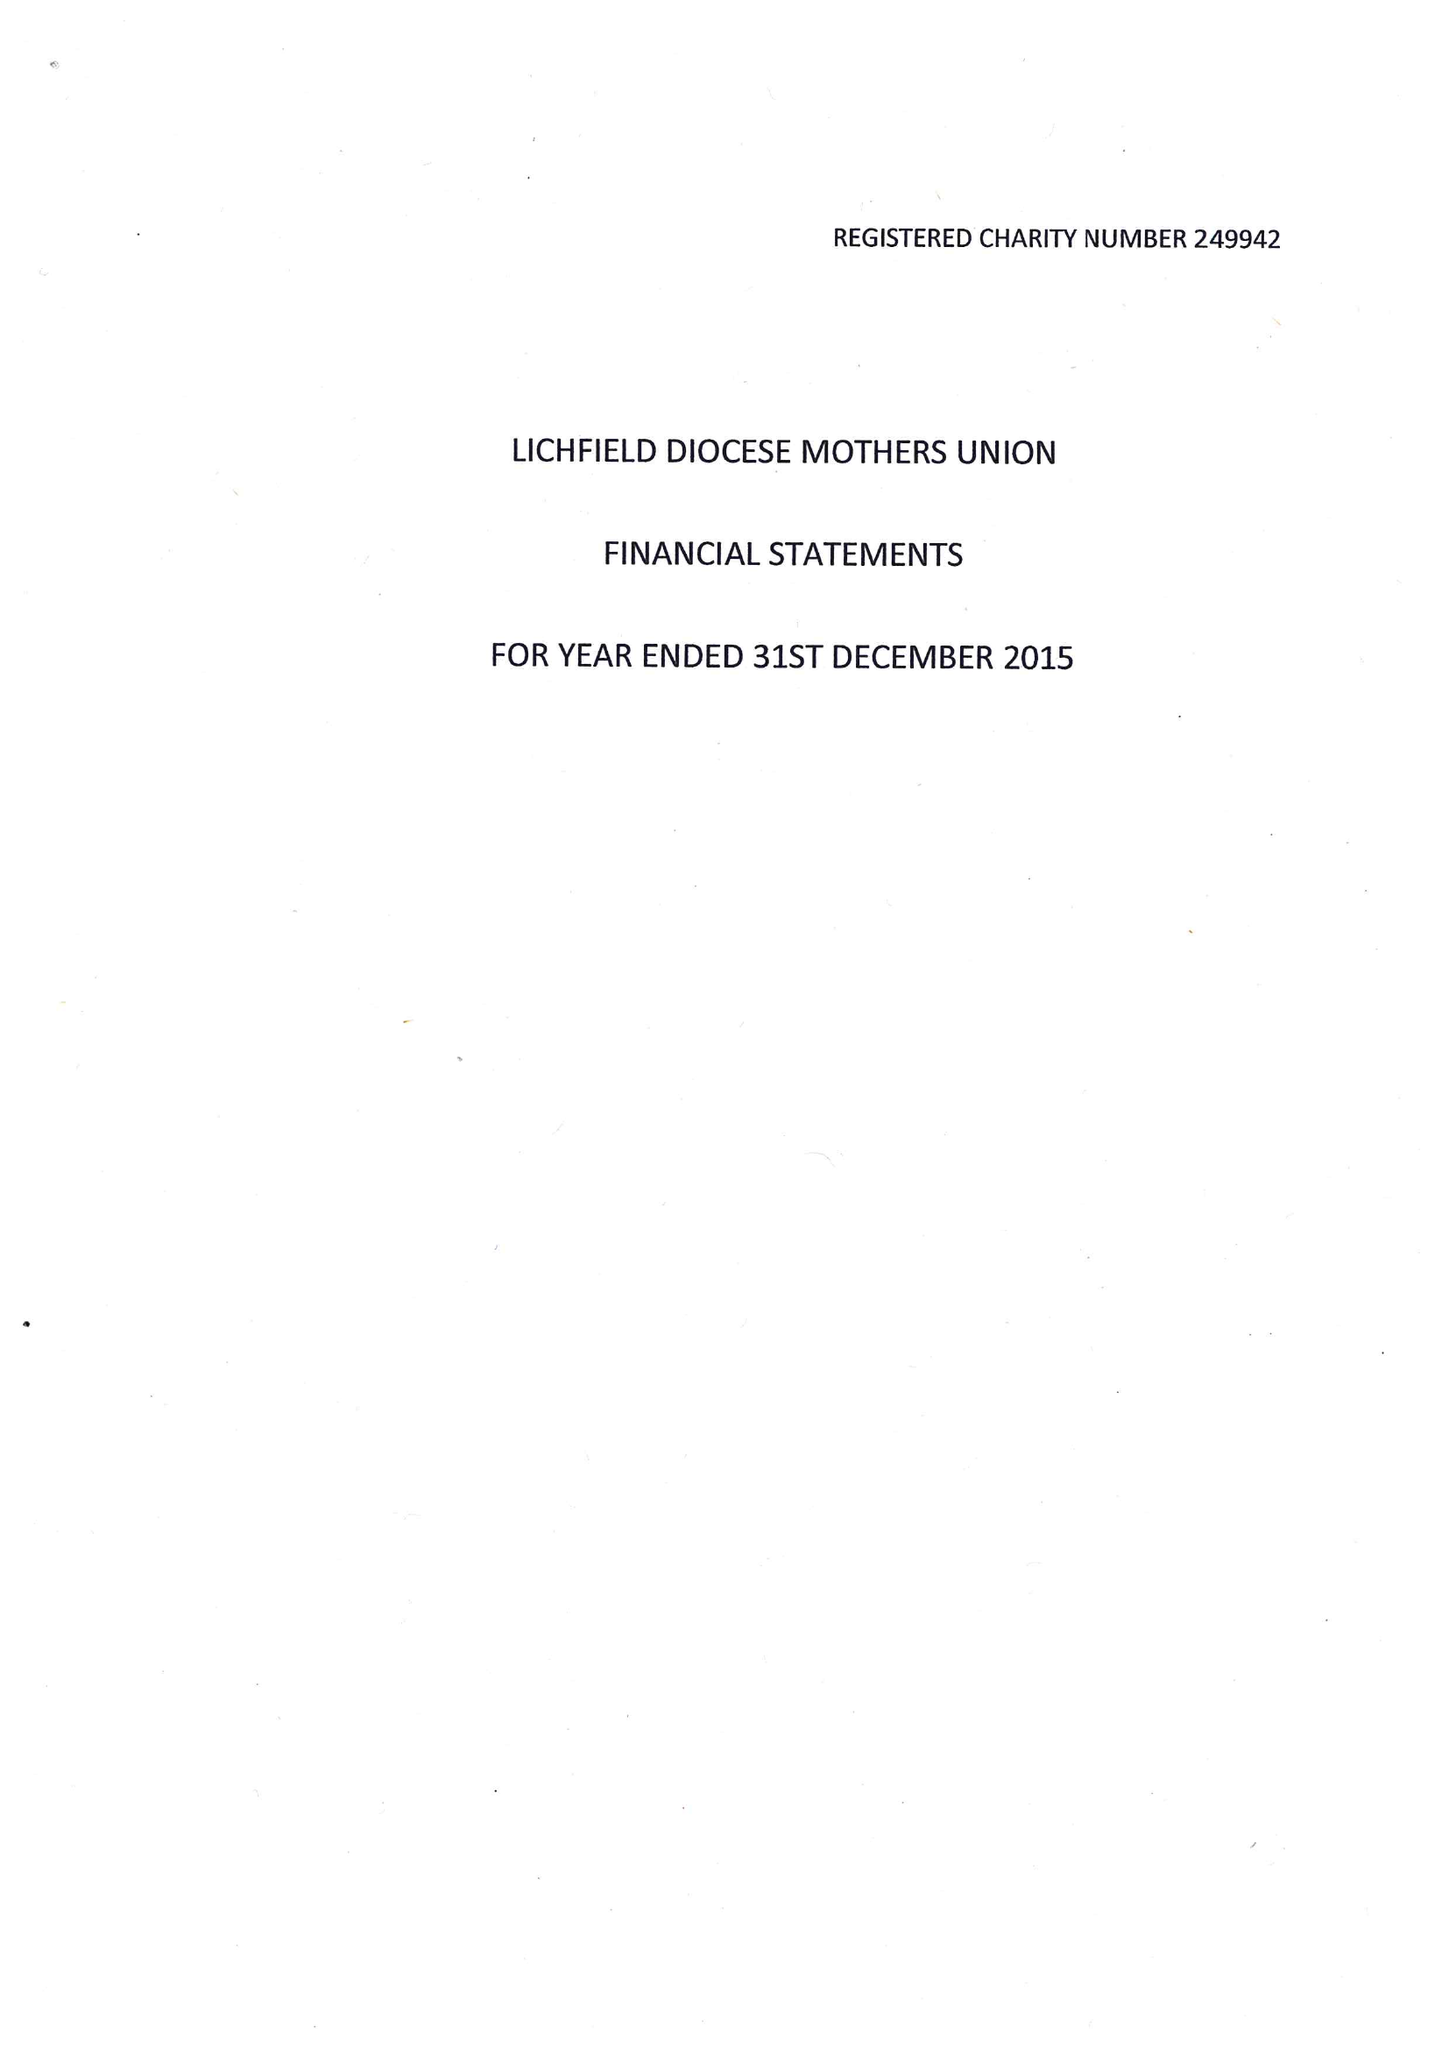What is the value for the address__post_town?
Answer the question using a single word or phrase. LICHFIELD 